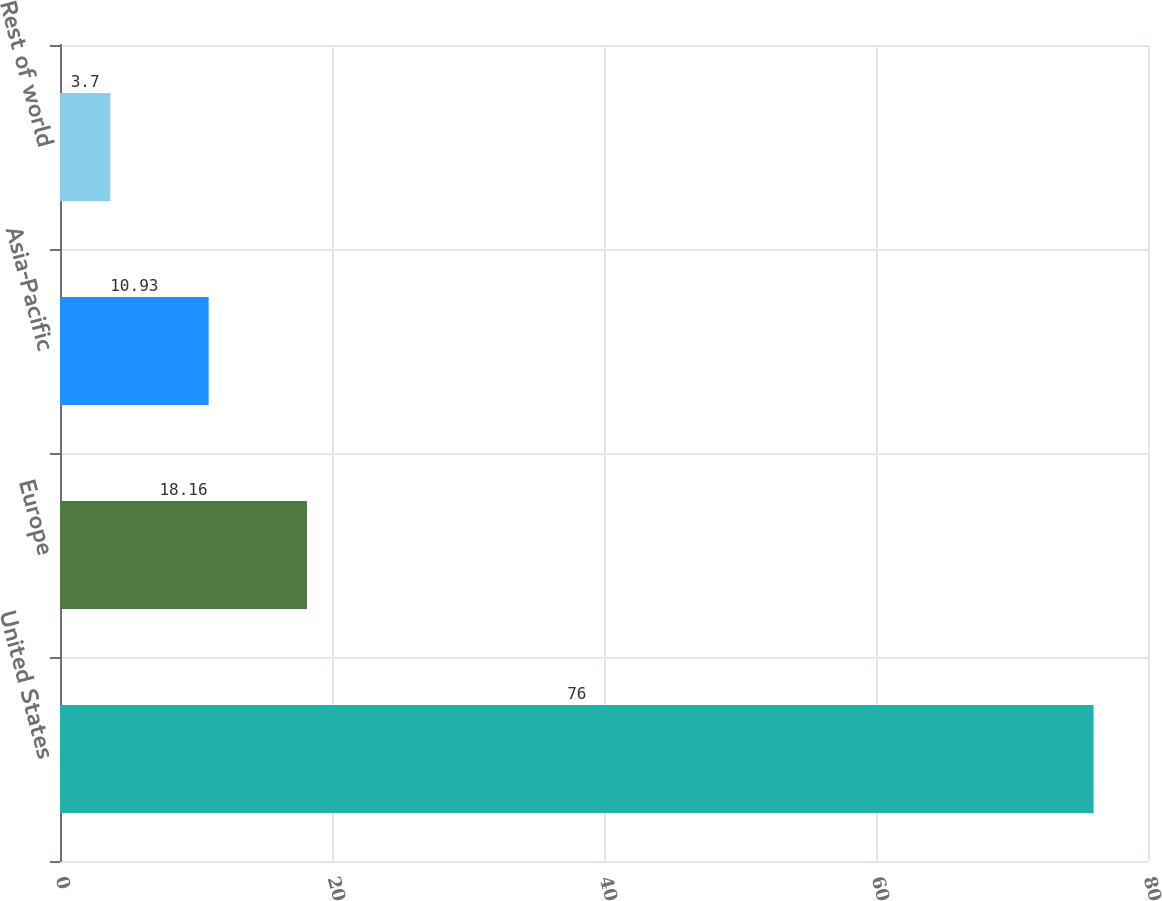Convert chart. <chart><loc_0><loc_0><loc_500><loc_500><bar_chart><fcel>United States<fcel>Europe<fcel>Asia-Pacific<fcel>Rest of world<nl><fcel>76<fcel>18.16<fcel>10.93<fcel>3.7<nl></chart> 